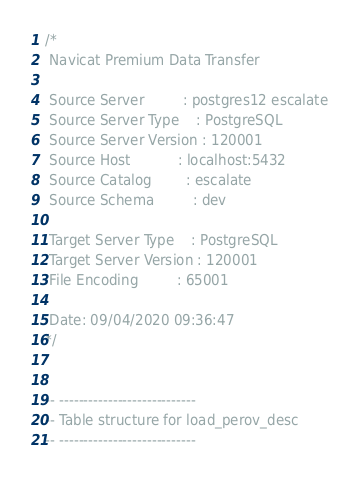<code> <loc_0><loc_0><loc_500><loc_500><_SQL_>/*
 Navicat Premium Data Transfer

 Source Server         : postgres12 escalate
 Source Server Type    : PostgreSQL
 Source Server Version : 120001
 Source Host           : localhost:5432
 Source Catalog        : escalate
 Source Schema         : dev

 Target Server Type    : PostgreSQL
 Target Server Version : 120001
 File Encoding         : 65001

 Date: 09/04/2020 09:36:47
*/


-- ----------------------------
-- Table structure for load_perov_desc
-- ----------------------------</code> 